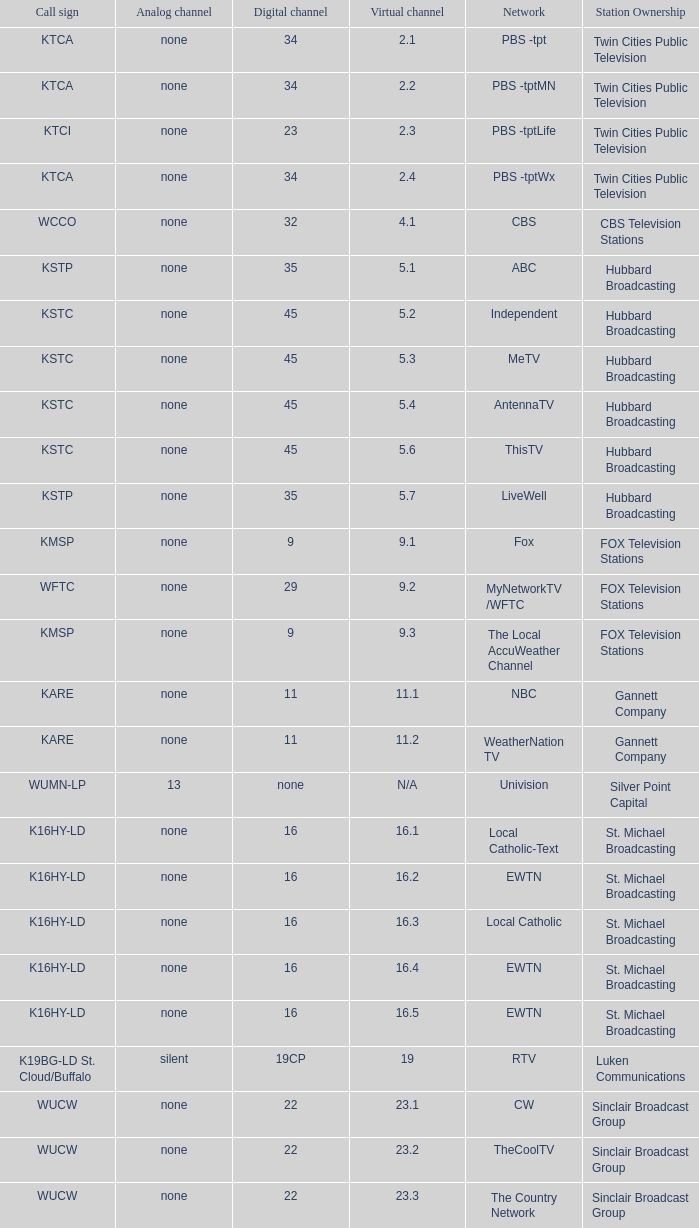Write the full table. {'header': ['Call sign', 'Analog channel', 'Digital channel', 'Virtual channel', 'Network', 'Station Ownership'], 'rows': [['KTCA', 'none', '34', '2.1', 'PBS -tpt', 'Twin Cities Public Television'], ['KTCA', 'none', '34', '2.2', 'PBS -tptMN', 'Twin Cities Public Television'], ['KTCI', 'none', '23', '2.3', 'PBS -tptLife', 'Twin Cities Public Television'], ['KTCA', 'none', '34', '2.4', 'PBS -tptWx', 'Twin Cities Public Television'], ['WCCO', 'none', '32', '4.1', 'CBS', 'CBS Television Stations'], ['KSTP', 'none', '35', '5.1', 'ABC', 'Hubbard Broadcasting'], ['KSTC', 'none', '45', '5.2', 'Independent', 'Hubbard Broadcasting'], ['KSTC', 'none', '45', '5.3', 'MeTV', 'Hubbard Broadcasting'], ['KSTC', 'none', '45', '5.4', 'AntennaTV', 'Hubbard Broadcasting'], ['KSTC', 'none', '45', '5.6', 'ThisTV', 'Hubbard Broadcasting'], ['KSTP', 'none', '35', '5.7', 'LiveWell', 'Hubbard Broadcasting'], ['KMSP', 'none', '9', '9.1', 'Fox', 'FOX Television Stations'], ['WFTC', 'none', '29', '9.2', 'MyNetworkTV /WFTC', 'FOX Television Stations'], ['KMSP', 'none', '9', '9.3', 'The Local AccuWeather Channel', 'FOX Television Stations'], ['KARE', 'none', '11', '11.1', 'NBC', 'Gannett Company'], ['KARE', 'none', '11', '11.2', 'WeatherNation TV', 'Gannett Company'], ['WUMN-LP', '13', 'none', 'N/A', 'Univision', 'Silver Point Capital'], ['K16HY-LD', 'none', '16', '16.1', 'Local Catholic-Text', 'St. Michael Broadcasting'], ['K16HY-LD', 'none', '16', '16.2', 'EWTN', 'St. Michael Broadcasting'], ['K16HY-LD', 'none', '16', '16.3', 'Local Catholic', 'St. Michael Broadcasting'], ['K16HY-LD', 'none', '16', '16.4', 'EWTN', 'St. Michael Broadcasting'], ['K16HY-LD', 'none', '16', '16.5', 'EWTN', 'St. Michael Broadcasting'], ['K19BG-LD St. Cloud/Buffalo', 'silent', '19CP', '19', 'RTV', 'Luken Communications'], ['WUCW', 'none', '22', '23.1', 'CW', 'Sinclair Broadcast Group'], ['WUCW', 'none', '22', '23.2', 'TheCoolTV', 'Sinclair Broadcast Group'], ['WUCW', 'none', '22', '23.3', 'The Country Network', 'Sinclair Broadcast Group'], ['KTCI', 'none', '23', '23.7~*', 'PBS -tptMN', 'Twin Cities Public Television'], ['K25IA-LD', 'none', '25', '25.1', 'TBN', 'Regal Media'], ['K25IA-LD', 'none', '25', '25.2', 'The Church Channel', 'Regal Media'], ['K25IA-LD', 'none', '25', '25.3', 'JCTV', 'Regal Media'], ['K25IA-LD', 'none', '25', '25.4', 'Smile Of A Child', 'Regal Media'], ['K25IA-LD', 'none', '25', '25.5', 'TBN Enlace', 'Regal Media'], ['W47CO-LD River Falls, Wisc.', 'none', '47', '28.1', 'PBS /WHWC', 'Wisconsin Public Television'], ['W47CO-LD River Falls, Wisc.', 'none', '47', '28.2', 'PBS -WISC/WHWC', 'Wisconsin Public Television'], ['W47CO-LD River Falls, Wisc.', 'none', '47', '28.3', 'PBS -Create/WHWC', 'Wisconsin Public Television'], ['WFTC', 'none', '29', '29.1', 'MyNetworkTV', 'FOX Television Stations'], ['KMSP', 'none', '9', '29.2', 'MyNetworkTV /WFTC', 'FOX Television Stations'], ['WFTC', 'none', '29', '29.3', 'Bounce TV', 'FOX Television Stations'], ['WFTC', 'none', '29', '29.4', 'Movies!', 'FOX Television Stations'], ['K33LN-LD', 'none', '33', '33.1', '3ABN', 'Three Angels Broadcasting Network'], ['K33LN-LD', 'none', '33', '33.2', '3ABN Proclaim!', 'Three Angels Broadcasting Network'], ['K33LN-LD', 'none', '33', '33.3', '3ABN Dare to Dream', 'Three Angels Broadcasting Network'], ['K33LN-LD', 'none', '33', '33.4', '3ABN Latino', 'Three Angels Broadcasting Network'], ['K33LN-LD', 'none', '33', '33.5', '3ABN Radio-Audio', 'Three Angels Broadcasting Network'], ['K33LN-LD', 'none', '33', '33.6', '3ABN Radio Latino-Audio', 'Three Angels Broadcasting Network'], ['K33LN-LD', 'none', '33', '33.7', 'Radio 74-Audio', 'Three Angels Broadcasting Network'], ['KPXM-TV', 'none', '40', '41.1', 'Ion Television', 'Ion Media Networks'], ['KPXM-TV', 'none', '40', '41.2', 'Qubo Kids', 'Ion Media Networks'], ['KPXM-TV', 'none', '40', '41.3', 'Ion Life', 'Ion Media Networks'], ['K43HB-LD', 'none', '43', '43.1', 'HSN', 'Ventana Television'], ['KHVM-LD', 'none', '48', '48.1', 'GCN - Religious', 'EICB TV'], ['KTCJ-LD', 'none', '50', '50.1', 'CTVN - Religious', 'EICB TV'], ['WDMI-LD', 'none', '31', '62.1', 'Daystar', 'Word of God Fellowship']]} Which analog channel is equivalent to digital channel 32? None. 